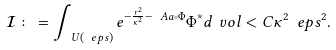Convert formula to latex. <formula><loc_0><loc_0><loc_500><loc_500>\mathcal { I } \colon = \int _ { \ U ( \ e p s ) } e ^ { - \frac { r ^ { 2 } } { \kappa ^ { 2 } } - \ A a \circ \Phi } \Phi ^ { * } d \ v o l < C \kappa ^ { 2 } \ e p s ^ { 2 } .</formula> 